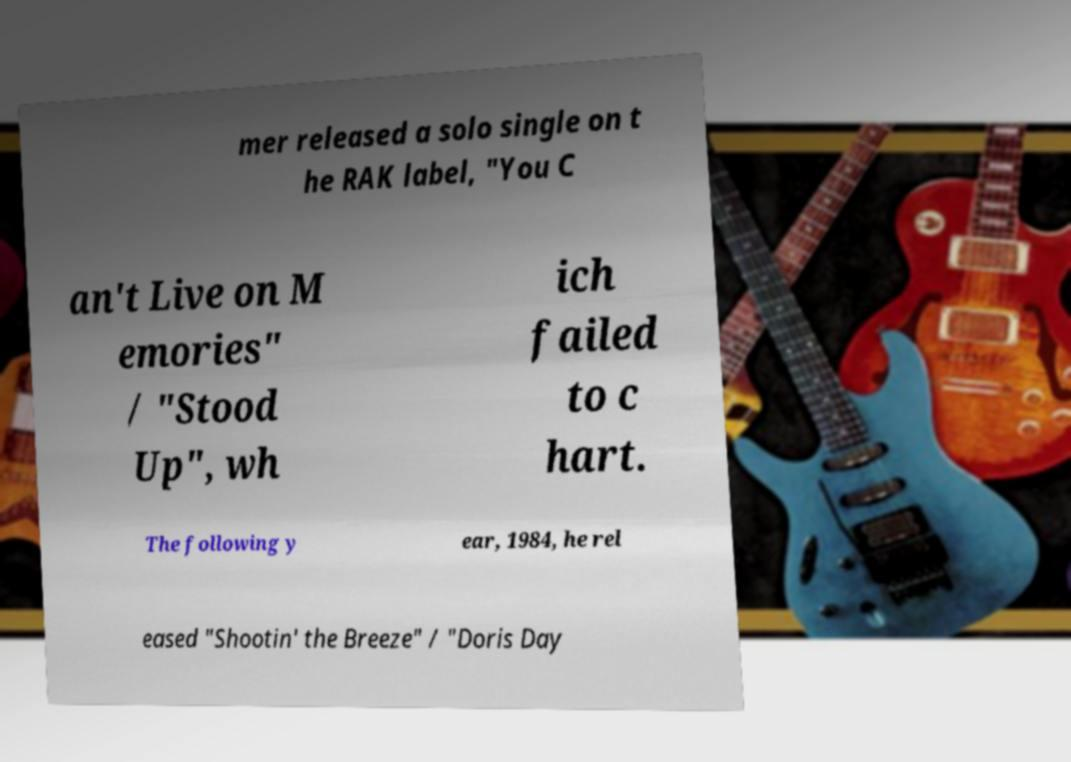Can you accurately transcribe the text from the provided image for me? mer released a solo single on t he RAK label, "You C an't Live on M emories" / "Stood Up", wh ich failed to c hart. The following y ear, 1984, he rel eased "Shootin' the Breeze" / "Doris Day 